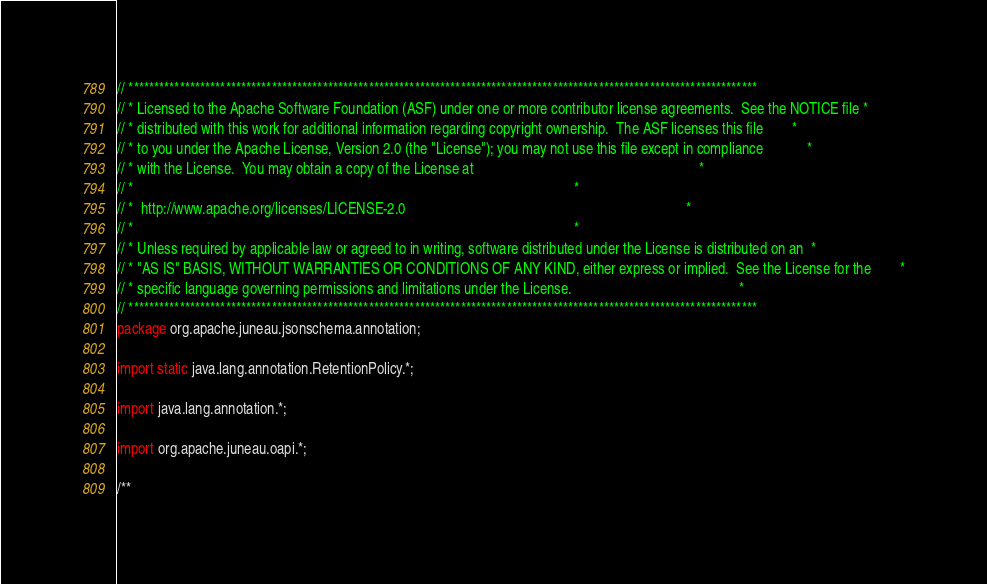Convert code to text. <code><loc_0><loc_0><loc_500><loc_500><_Java_>// ***************************************************************************************************************************
// * Licensed to the Apache Software Foundation (ASF) under one or more contributor license agreements.  See the NOTICE file *
// * distributed with this work for additional information regarding copyright ownership.  The ASF licenses this file        *
// * to you under the Apache License, Version 2.0 (the "License"); you may not use this file except in compliance            *
// * with the License.  You may obtain a copy of the License at                                                              *
// *                                                                                                                         *
// *  http://www.apache.org/licenses/LICENSE-2.0                                                                             *
// *                                                                                                                         *
// * Unless required by applicable law or agreed to in writing, software distributed under the License is distributed on an  *
// * "AS IS" BASIS, WITHOUT WARRANTIES OR CONDITIONS OF ANY KIND, either express or implied.  See the License for the        *
// * specific language governing permissions and limitations under the License.                                              *
// ***************************************************************************************************************************
package org.apache.juneau.jsonschema.annotation;

import static java.lang.annotation.RetentionPolicy.*;

import java.lang.annotation.*;

import org.apache.juneau.oapi.*;

/**</code> 